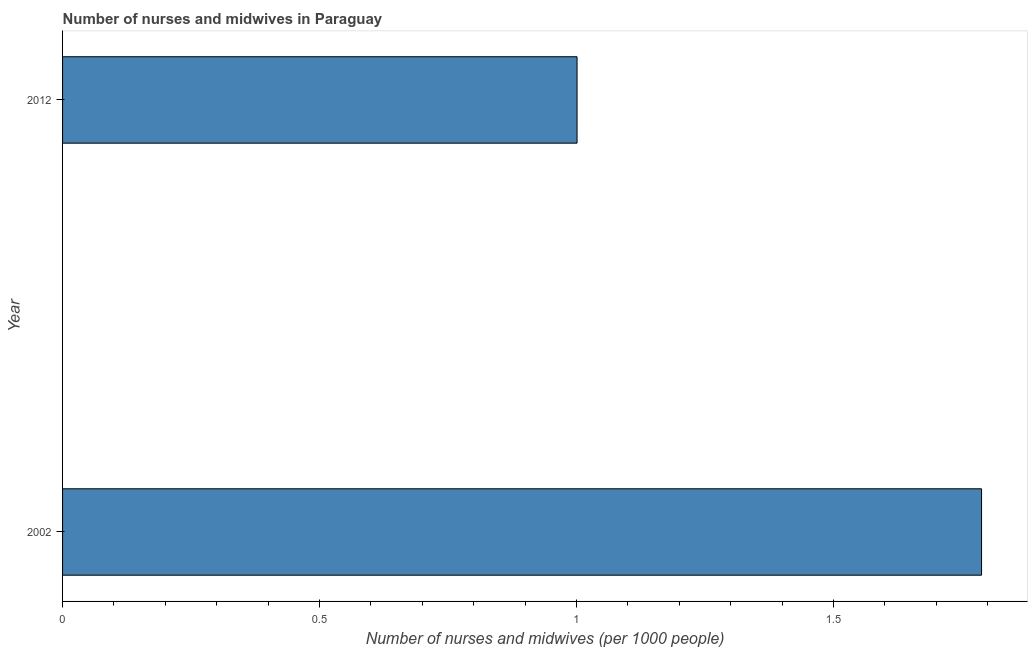Does the graph contain any zero values?
Your response must be concise. No. What is the title of the graph?
Make the answer very short. Number of nurses and midwives in Paraguay. What is the label or title of the X-axis?
Ensure brevity in your answer.  Number of nurses and midwives (per 1000 people). What is the number of nurses and midwives in 2002?
Keep it short and to the point. 1.79. Across all years, what is the maximum number of nurses and midwives?
Ensure brevity in your answer.  1.79. Across all years, what is the minimum number of nurses and midwives?
Provide a succinct answer. 1. In which year was the number of nurses and midwives maximum?
Your answer should be very brief. 2002. What is the sum of the number of nurses and midwives?
Your answer should be very brief. 2.79. What is the difference between the number of nurses and midwives in 2002 and 2012?
Your answer should be very brief. 0.79. What is the average number of nurses and midwives per year?
Provide a short and direct response. 1.39. What is the median number of nurses and midwives?
Ensure brevity in your answer.  1.39. What is the ratio of the number of nurses and midwives in 2002 to that in 2012?
Your answer should be very brief. 1.79. Is the number of nurses and midwives in 2002 less than that in 2012?
Offer a terse response. No. Are all the bars in the graph horizontal?
Offer a terse response. Yes. Are the values on the major ticks of X-axis written in scientific E-notation?
Ensure brevity in your answer.  No. What is the Number of nurses and midwives (per 1000 people) in 2002?
Offer a very short reply. 1.79. What is the Number of nurses and midwives (per 1000 people) in 2012?
Ensure brevity in your answer.  1. What is the difference between the Number of nurses and midwives (per 1000 people) in 2002 and 2012?
Give a very brief answer. 0.79. What is the ratio of the Number of nurses and midwives (per 1000 people) in 2002 to that in 2012?
Make the answer very short. 1.79. 